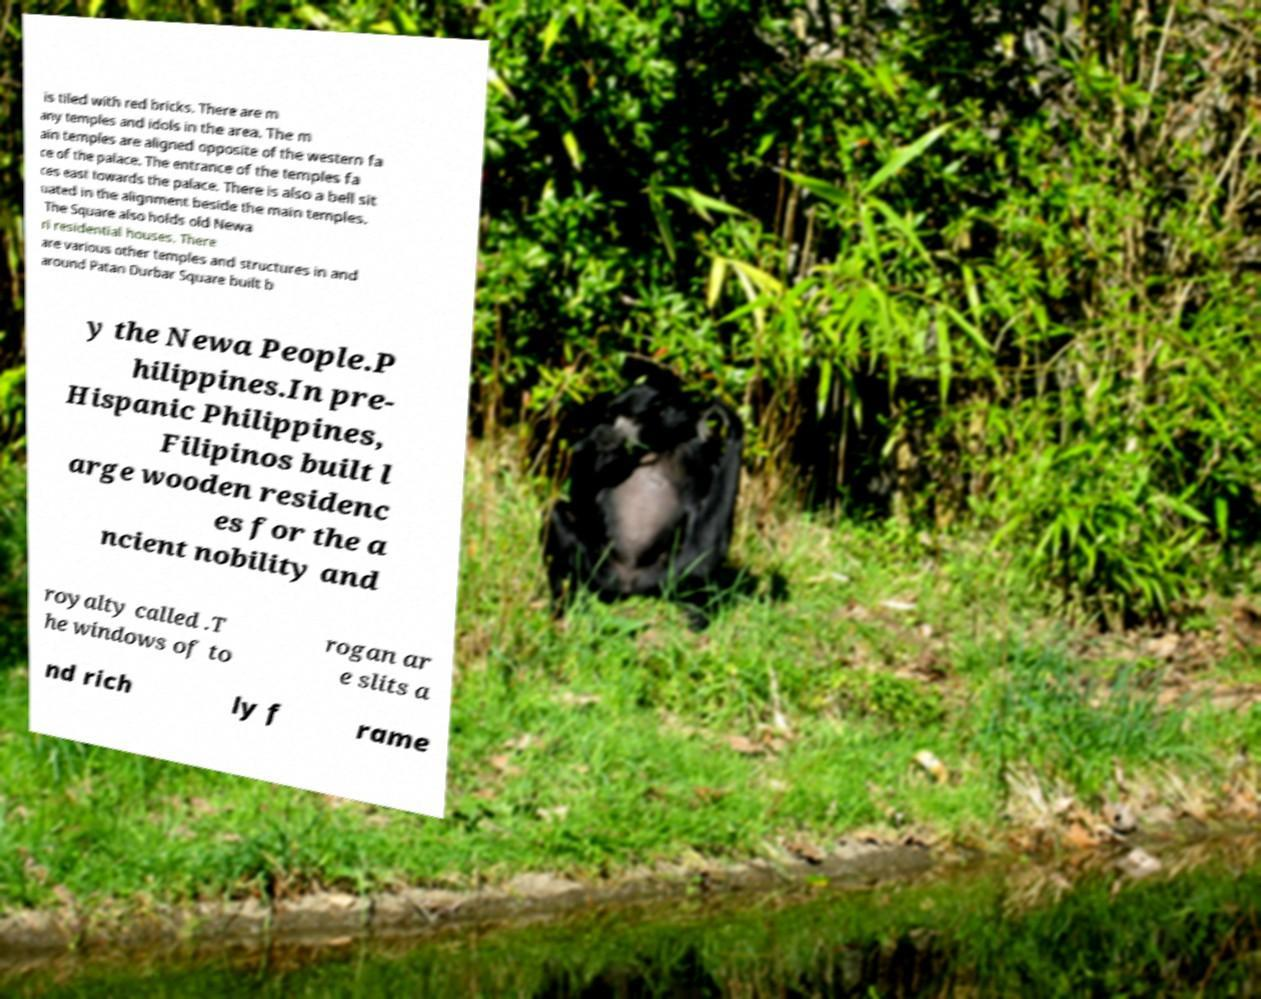Please identify and transcribe the text found in this image. is tiled with red bricks. There are m any temples and idols in the area. The m ain temples are aligned opposite of the western fa ce of the palace. The entrance of the temples fa ces east towards the palace. There is also a bell sit uated in the alignment beside the main temples. The Square also holds old Newa ri residential houses. There are various other temples and structures in and around Patan Durbar Square built b y the Newa People.P hilippines.In pre- Hispanic Philippines, Filipinos built l arge wooden residenc es for the a ncient nobility and royalty called .T he windows of to rogan ar e slits a nd rich ly f rame 